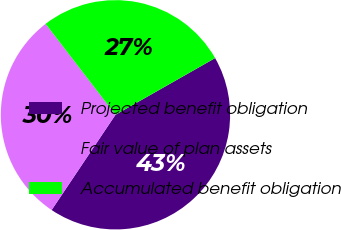Convert chart. <chart><loc_0><loc_0><loc_500><loc_500><pie_chart><fcel>Projected benefit obligation<fcel>Fair value of plan assets<fcel>Accumulated benefit obligation<nl><fcel>42.63%<fcel>30.17%<fcel>27.2%<nl></chart> 